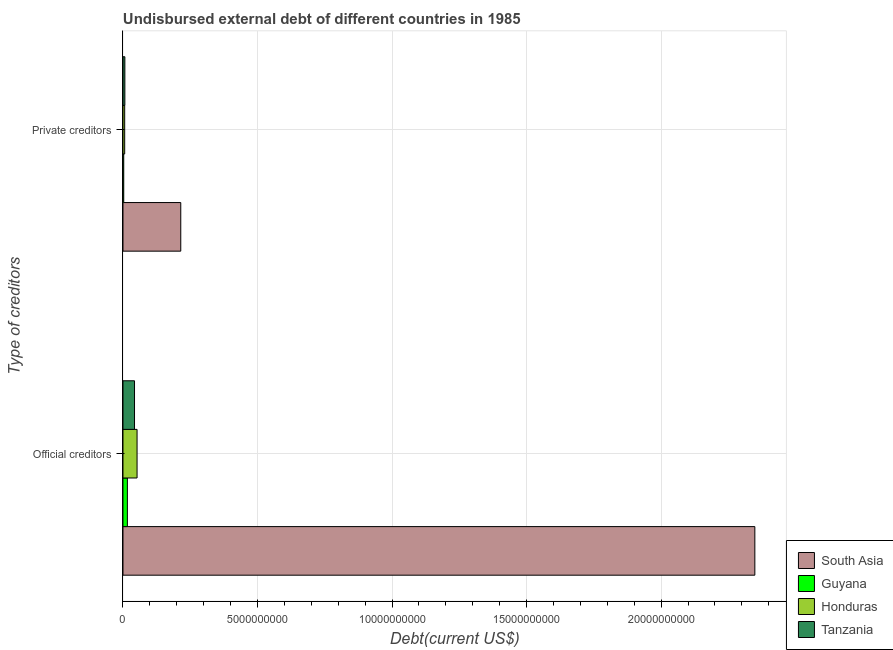Are the number of bars per tick equal to the number of legend labels?
Offer a terse response. Yes. How many bars are there on the 2nd tick from the top?
Keep it short and to the point. 4. How many bars are there on the 1st tick from the bottom?
Your answer should be compact. 4. What is the label of the 1st group of bars from the top?
Your answer should be compact. Private creditors. What is the undisbursed external debt of private creditors in Guyana?
Give a very brief answer. 2.79e+07. Across all countries, what is the maximum undisbursed external debt of official creditors?
Your answer should be compact. 2.35e+1. Across all countries, what is the minimum undisbursed external debt of official creditors?
Your answer should be very brief. 1.64e+08. In which country was the undisbursed external debt of official creditors minimum?
Your answer should be compact. Guyana. What is the total undisbursed external debt of official creditors in the graph?
Give a very brief answer. 2.46e+1. What is the difference between the undisbursed external debt of official creditors in South Asia and that in Tanzania?
Provide a short and direct response. 2.31e+1. What is the difference between the undisbursed external debt of official creditors in Honduras and the undisbursed external debt of private creditors in Guyana?
Provide a succinct answer. 4.96e+08. What is the average undisbursed external debt of official creditors per country?
Offer a very short reply. 6.15e+09. What is the difference between the undisbursed external debt of official creditors and undisbursed external debt of private creditors in Honduras?
Provide a succinct answer. 4.60e+08. In how many countries, is the undisbursed external debt of private creditors greater than 13000000000 US$?
Offer a very short reply. 0. What is the ratio of the undisbursed external debt of private creditors in Honduras to that in Guyana?
Keep it short and to the point. 2.27. Is the undisbursed external debt of private creditors in Guyana less than that in Tanzania?
Offer a terse response. Yes. In how many countries, is the undisbursed external debt of private creditors greater than the average undisbursed external debt of private creditors taken over all countries?
Provide a succinct answer. 1. What does the 2nd bar from the top in Private creditors represents?
Ensure brevity in your answer.  Honduras. What does the 1st bar from the bottom in Official creditors represents?
Your response must be concise. South Asia. Are all the bars in the graph horizontal?
Your answer should be very brief. Yes. Are the values on the major ticks of X-axis written in scientific E-notation?
Keep it short and to the point. No. How many legend labels are there?
Your answer should be very brief. 4. How are the legend labels stacked?
Provide a short and direct response. Vertical. What is the title of the graph?
Provide a short and direct response. Undisbursed external debt of different countries in 1985. Does "Sudan" appear as one of the legend labels in the graph?
Your response must be concise. No. What is the label or title of the X-axis?
Make the answer very short. Debt(current US$). What is the label or title of the Y-axis?
Your answer should be compact. Type of creditors. What is the Debt(current US$) of South Asia in Official creditors?
Offer a very short reply. 2.35e+1. What is the Debt(current US$) in Guyana in Official creditors?
Provide a succinct answer. 1.64e+08. What is the Debt(current US$) in Honduras in Official creditors?
Offer a terse response. 5.24e+08. What is the Debt(current US$) of Tanzania in Official creditors?
Keep it short and to the point. 4.29e+08. What is the Debt(current US$) of South Asia in Private creditors?
Give a very brief answer. 2.15e+09. What is the Debt(current US$) of Guyana in Private creditors?
Your answer should be very brief. 2.79e+07. What is the Debt(current US$) of Honduras in Private creditors?
Your answer should be compact. 6.33e+07. What is the Debt(current US$) of Tanzania in Private creditors?
Keep it short and to the point. 7.01e+07. Across all Type of creditors, what is the maximum Debt(current US$) of South Asia?
Provide a succinct answer. 2.35e+1. Across all Type of creditors, what is the maximum Debt(current US$) of Guyana?
Offer a very short reply. 1.64e+08. Across all Type of creditors, what is the maximum Debt(current US$) in Honduras?
Provide a succinct answer. 5.24e+08. Across all Type of creditors, what is the maximum Debt(current US$) of Tanzania?
Keep it short and to the point. 4.29e+08. Across all Type of creditors, what is the minimum Debt(current US$) of South Asia?
Provide a succinct answer. 2.15e+09. Across all Type of creditors, what is the minimum Debt(current US$) of Guyana?
Give a very brief answer. 2.79e+07. Across all Type of creditors, what is the minimum Debt(current US$) in Honduras?
Your answer should be very brief. 6.33e+07. Across all Type of creditors, what is the minimum Debt(current US$) in Tanzania?
Make the answer very short. 7.01e+07. What is the total Debt(current US$) of South Asia in the graph?
Provide a succinct answer. 2.56e+1. What is the total Debt(current US$) of Guyana in the graph?
Give a very brief answer. 1.92e+08. What is the total Debt(current US$) in Honduras in the graph?
Offer a very short reply. 5.87e+08. What is the total Debt(current US$) in Tanzania in the graph?
Make the answer very short. 4.99e+08. What is the difference between the Debt(current US$) in South Asia in Official creditors and that in Private creditors?
Keep it short and to the point. 2.13e+1. What is the difference between the Debt(current US$) of Guyana in Official creditors and that in Private creditors?
Offer a terse response. 1.36e+08. What is the difference between the Debt(current US$) in Honduras in Official creditors and that in Private creditors?
Your answer should be compact. 4.60e+08. What is the difference between the Debt(current US$) in Tanzania in Official creditors and that in Private creditors?
Provide a short and direct response. 3.59e+08. What is the difference between the Debt(current US$) in South Asia in Official creditors and the Debt(current US$) in Guyana in Private creditors?
Offer a terse response. 2.35e+1. What is the difference between the Debt(current US$) in South Asia in Official creditors and the Debt(current US$) in Honduras in Private creditors?
Offer a very short reply. 2.34e+1. What is the difference between the Debt(current US$) in South Asia in Official creditors and the Debt(current US$) in Tanzania in Private creditors?
Offer a very short reply. 2.34e+1. What is the difference between the Debt(current US$) of Guyana in Official creditors and the Debt(current US$) of Honduras in Private creditors?
Offer a very short reply. 1.01e+08. What is the difference between the Debt(current US$) in Guyana in Official creditors and the Debt(current US$) in Tanzania in Private creditors?
Your answer should be very brief. 9.41e+07. What is the difference between the Debt(current US$) in Honduras in Official creditors and the Debt(current US$) in Tanzania in Private creditors?
Offer a terse response. 4.53e+08. What is the average Debt(current US$) of South Asia per Type of creditors?
Give a very brief answer. 1.28e+1. What is the average Debt(current US$) in Guyana per Type of creditors?
Make the answer very short. 9.60e+07. What is the average Debt(current US$) in Honduras per Type of creditors?
Your answer should be compact. 2.93e+08. What is the average Debt(current US$) in Tanzania per Type of creditors?
Offer a terse response. 2.49e+08. What is the difference between the Debt(current US$) in South Asia and Debt(current US$) in Guyana in Official creditors?
Keep it short and to the point. 2.33e+1. What is the difference between the Debt(current US$) of South Asia and Debt(current US$) of Honduras in Official creditors?
Give a very brief answer. 2.30e+1. What is the difference between the Debt(current US$) in South Asia and Debt(current US$) in Tanzania in Official creditors?
Your answer should be compact. 2.31e+1. What is the difference between the Debt(current US$) in Guyana and Debt(current US$) in Honduras in Official creditors?
Offer a very short reply. -3.59e+08. What is the difference between the Debt(current US$) of Guyana and Debt(current US$) of Tanzania in Official creditors?
Make the answer very short. -2.65e+08. What is the difference between the Debt(current US$) in Honduras and Debt(current US$) in Tanzania in Official creditors?
Offer a terse response. 9.47e+07. What is the difference between the Debt(current US$) in South Asia and Debt(current US$) in Guyana in Private creditors?
Offer a very short reply. 2.12e+09. What is the difference between the Debt(current US$) of South Asia and Debt(current US$) of Honduras in Private creditors?
Ensure brevity in your answer.  2.08e+09. What is the difference between the Debt(current US$) in South Asia and Debt(current US$) in Tanzania in Private creditors?
Provide a succinct answer. 2.08e+09. What is the difference between the Debt(current US$) of Guyana and Debt(current US$) of Honduras in Private creditors?
Ensure brevity in your answer.  -3.55e+07. What is the difference between the Debt(current US$) in Guyana and Debt(current US$) in Tanzania in Private creditors?
Your answer should be very brief. -4.23e+07. What is the difference between the Debt(current US$) in Honduras and Debt(current US$) in Tanzania in Private creditors?
Offer a terse response. -6.78e+06. What is the ratio of the Debt(current US$) in South Asia in Official creditors to that in Private creditors?
Offer a terse response. 10.94. What is the ratio of the Debt(current US$) of Guyana in Official creditors to that in Private creditors?
Provide a succinct answer. 5.89. What is the ratio of the Debt(current US$) of Honduras in Official creditors to that in Private creditors?
Your answer should be compact. 8.26. What is the ratio of the Debt(current US$) of Tanzania in Official creditors to that in Private creditors?
Offer a terse response. 6.12. What is the difference between the highest and the second highest Debt(current US$) of South Asia?
Make the answer very short. 2.13e+1. What is the difference between the highest and the second highest Debt(current US$) in Guyana?
Keep it short and to the point. 1.36e+08. What is the difference between the highest and the second highest Debt(current US$) in Honduras?
Your answer should be very brief. 4.60e+08. What is the difference between the highest and the second highest Debt(current US$) of Tanzania?
Ensure brevity in your answer.  3.59e+08. What is the difference between the highest and the lowest Debt(current US$) of South Asia?
Provide a succinct answer. 2.13e+1. What is the difference between the highest and the lowest Debt(current US$) in Guyana?
Offer a terse response. 1.36e+08. What is the difference between the highest and the lowest Debt(current US$) of Honduras?
Your answer should be compact. 4.60e+08. What is the difference between the highest and the lowest Debt(current US$) of Tanzania?
Offer a very short reply. 3.59e+08. 